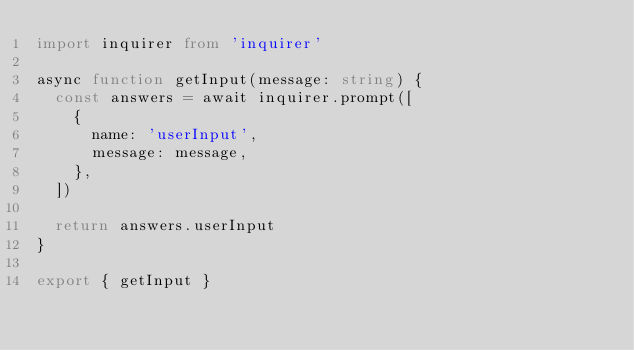Convert code to text. <code><loc_0><loc_0><loc_500><loc_500><_TypeScript_>import inquirer from 'inquirer'

async function getInput(message: string) {
  const answers = await inquirer.prompt([
    {
      name: 'userInput',
      message: message,
    },
  ])

  return answers.userInput
}

export { getInput }
</code> 